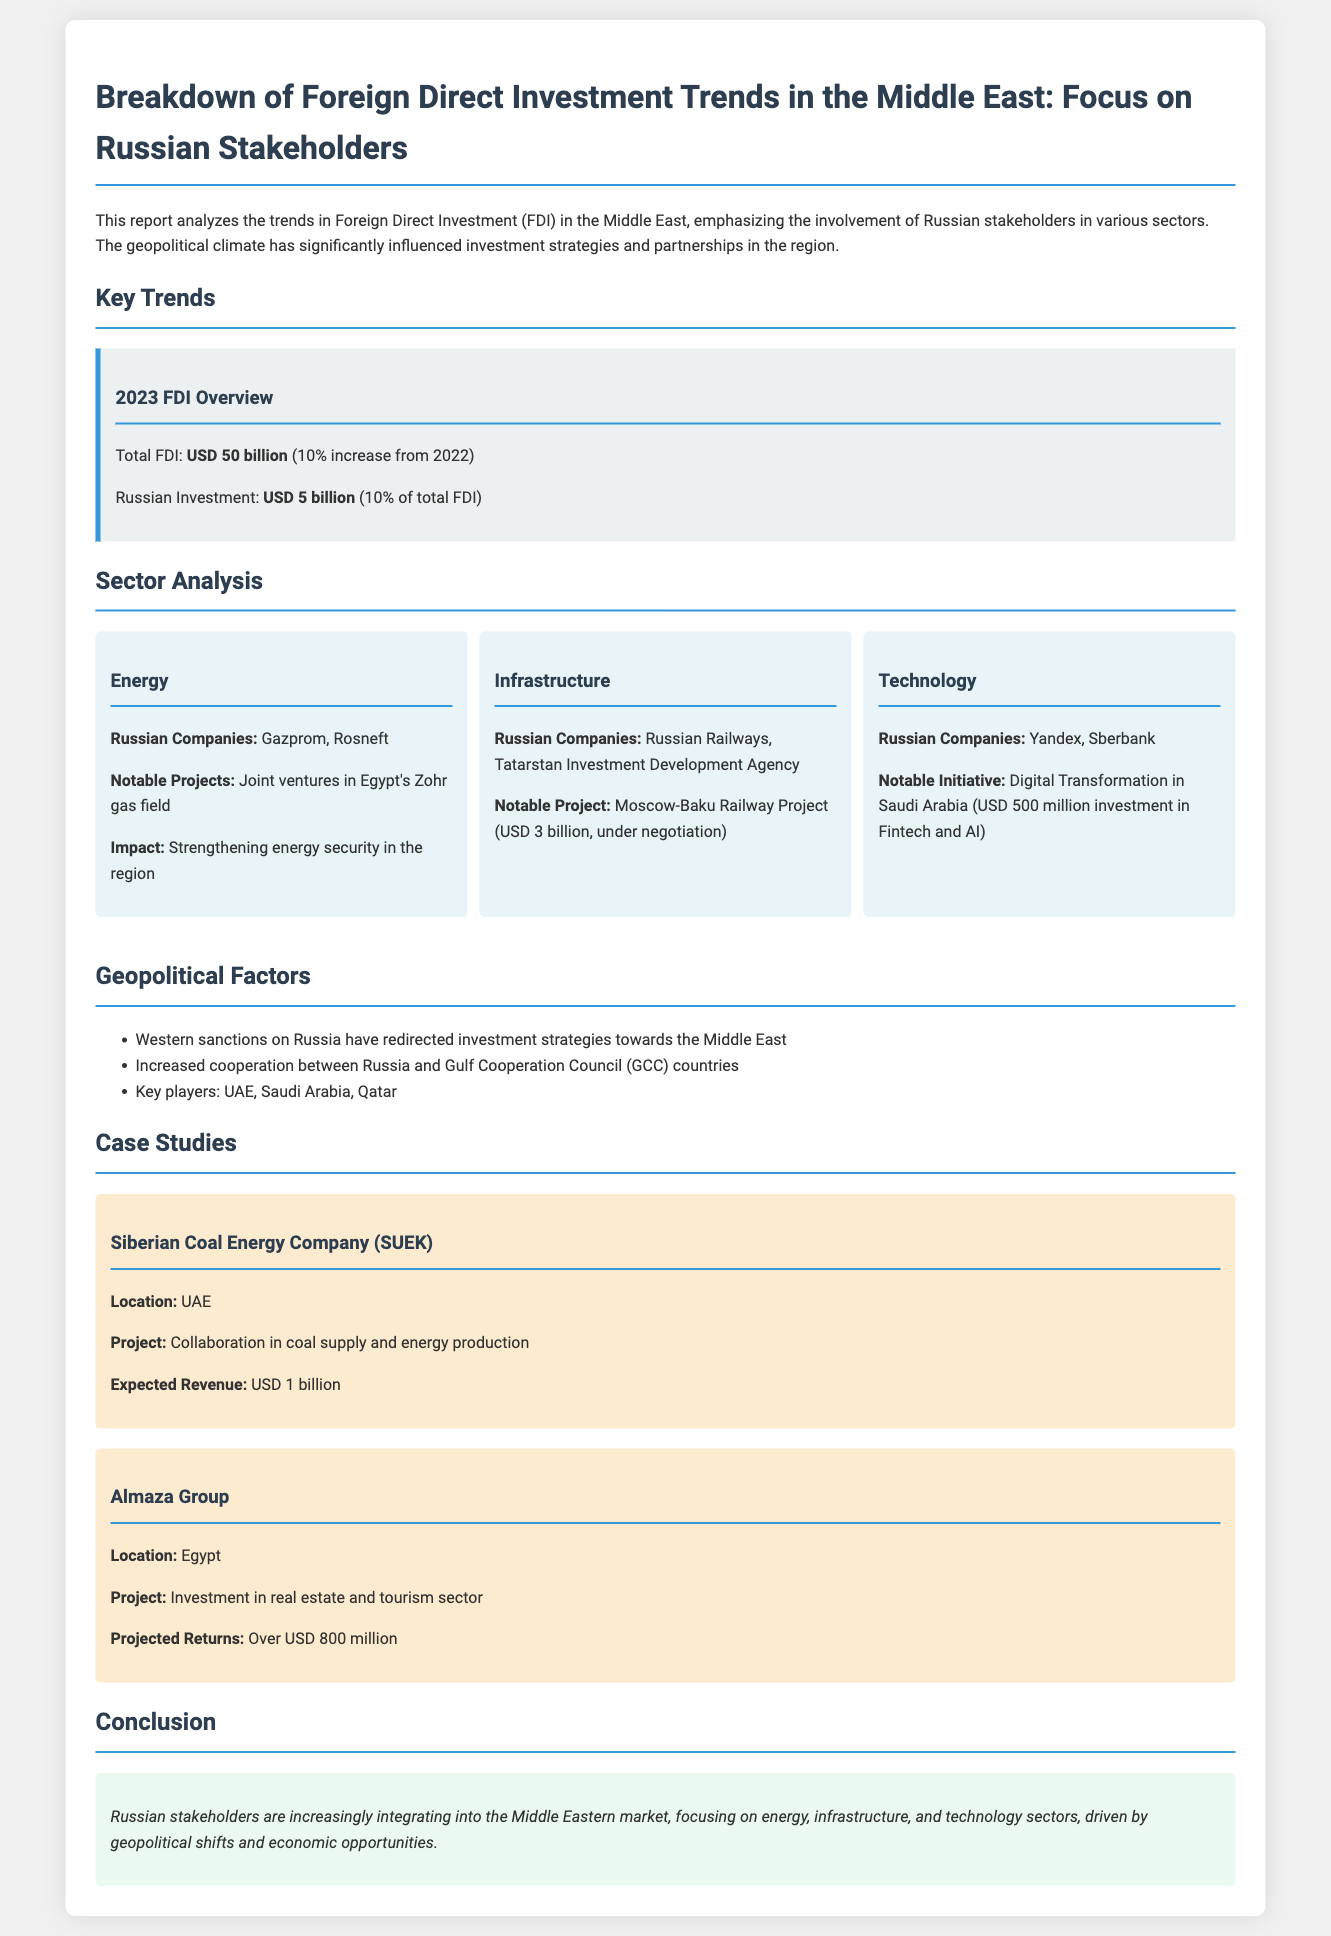What was the total FDI in 2023? The total Foreign Direct Investment (FDI) in 2023 is highlighted as USD 50 billion.
Answer: USD 50 billion What percentage of the total FDI did Russian investment account for? The report states that Russian investment accounted for 10% of the total FDI in 2023.
Answer: 10% Which Russian company is involved in Egypt's Zohr gas field? The document lists Gazprom and Rosneft as Russian companies involved in the Zohr gas field.
Answer: Gazprom, Rosneft What is the expected revenue from the Siberian Coal Energy Company project? The expected revenue from the project collaboration in the UAE is stated as USD 1 billion.
Answer: USD 1 billion Which sector received a USD 500 million investment in Saudi Arabia? The document specifies that the technology sector, focusing on Fintech and AI, received this investment.
Answer: Technology What geopolitical factor has redirected Russian investment strategies? The overview indicates that Western sanctions on Russia have redirected investment strategies towards the Middle East.
Answer: Western sanctions What notable project is associated with the infrastructure sector? The Moscow-Baku Railway Project is mentioned as a notable project in the infrastructure sector worth USD 3 billion.
Answer: Moscow-Baku Railway Project What is the projected return from the Almaza Group's investment in Egypt? The report mentions that the projected returns from this investment are over USD 800 million.
Answer: Over USD 800 million Which three key players are mentioned regarding cooperation between Russia and GCC countries? The report lists UAE, Saudi Arabia, and Qatar as key players in this cooperation.
Answer: UAE, Saudi Arabia, Qatar 